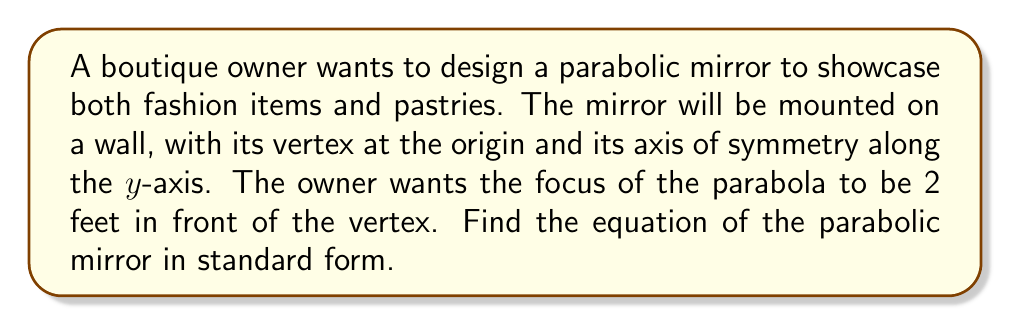Can you solve this math problem? Let's approach this step-by-step:

1) The general equation of a parabola with its vertex at the origin and its axis of symmetry along the y-axis is:

   $$x^2 = 4py$$

   where $p$ is the distance from the vertex to the focus.

2) We're given that the focus is 2 feet in front of the vertex. Since the vertex is at the origin and the parabola opens upward, this means the focus is at the point (0, 2).

3) Therefore, $p = 2$.

4) Substituting this into our general equation:

   $$x^2 = 4(2)y$$

5) Simplify:

   $$x^2 = 8y$$

This is the equation of the parabolic mirror in standard form.

[asy]
import graph;
size(200);
real f(real x) {return x^2/8;}
draw(graph(f,-4,4));
dot((0,2),red);
label("Focus (0,2)",(0,2),N);
dot((0,0));
label("Vertex (0,0)",(0,0),SW);
draw((-4,0)--(4,0),gray);
draw((0,-1)--(0,4),gray);
label("x",4.5,0);
label("y",0,4.5);
[/asy]
Answer: $$x^2 = 8y$$ 